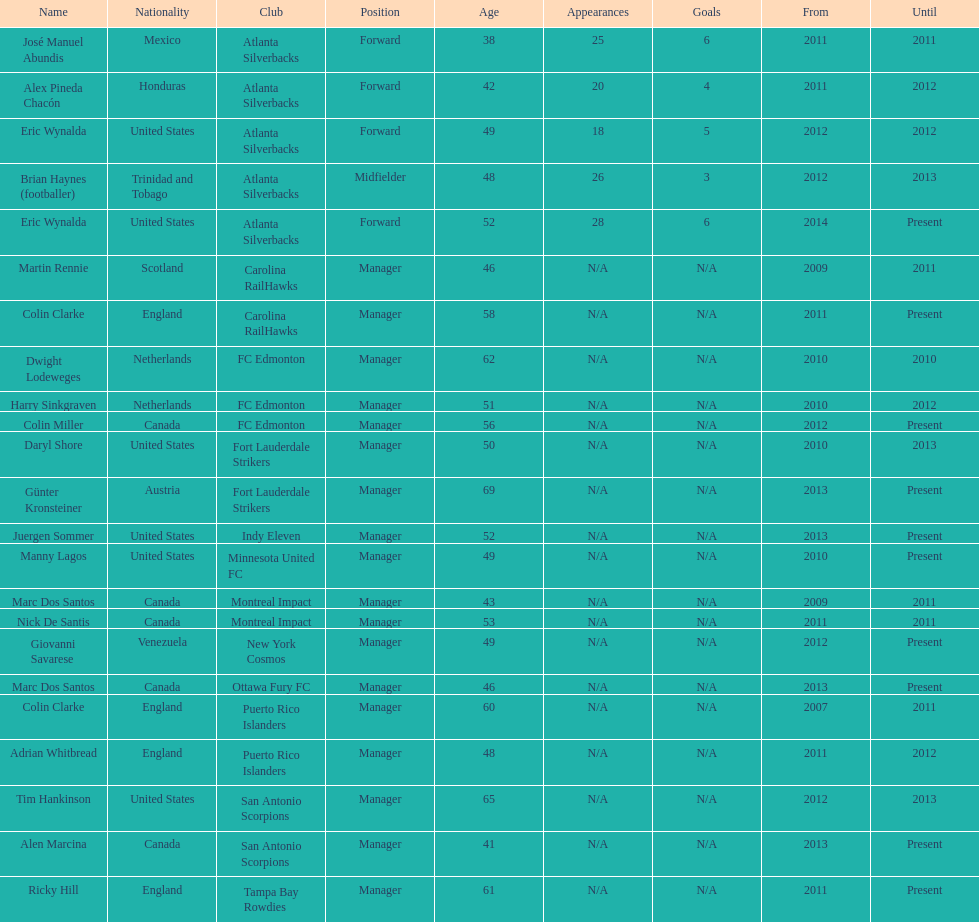How long did colin clarke coach the puerto rico islanders for? 4 years. 